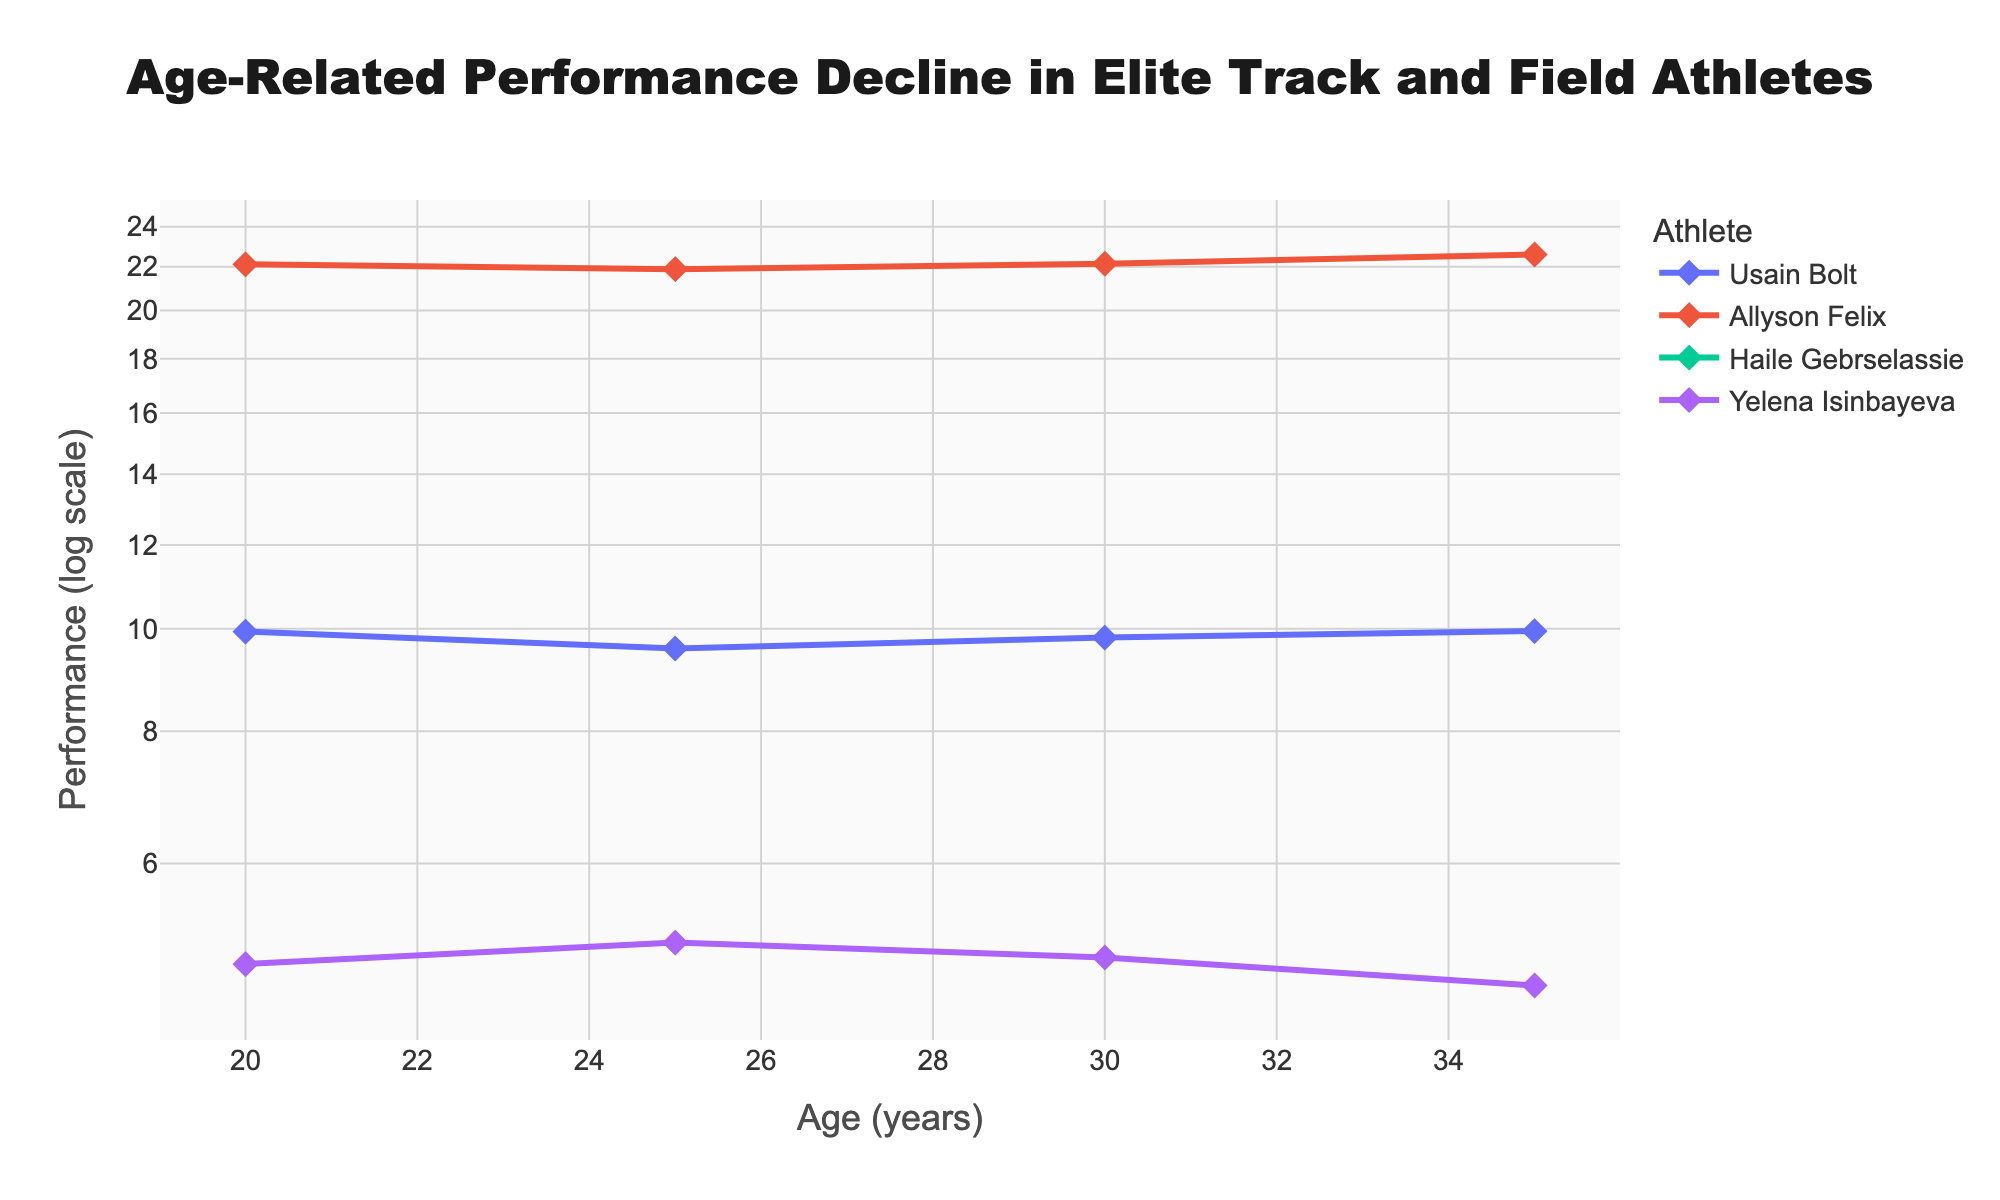What is the title of the figure? The title is typically found at the top of the figure. This one says, "Age-Related Performance Decline in Elite Track and Field Athletes" which clearly indicates the focus of the analysis.
Answer: Age-Related Performance Decline in Elite Track and Field Athletes What is the x-axis labeled with? The x-axis label usually indicates the metric measured along this axis. In this figure, it is labeled with "Age (years)" which shows the age of the athletes.
Answer: Age (years) What is the y-axis labeled with, and what scale is it using? The y-axis label provides information about the metric and scaling used. In this figure, it is labeled "Performance (log scale)," indicating that performance is measured on a logarithmic scale.
Answer: Performance (log scale) How many data points are plotted for Usain Bolt? Each marker on the line represents a data point for the athlete. Usain Bolt's line has markers at ages 20, 25, 30, and 35, which totals to 4 data points.
Answer: 4 At what age did Yelena Isinbayeva achieve her highest performance? By examining the heights of the markers along Yelena Isinbayeva's line, her highest point is at age 25.
Answer: 25 Which athlete shows the smallest performance decline from age 20 to age 25? To determine this, compare the vertical gaps between the performances at ages 20 and 25 across all athletes. Allyson Felix has the smallest decline as her performance slightly improves.
Answer: Allyson Felix How does Allyson Felix's performance at age 35 compare to her performance at age 20? Looking at both markers, Allyson Felix's performance at age 35 is slower compared to age 20. Specifically, it went from 22.11 seconds to 22.59 seconds.
Answer: It's slower at age 35 Who had the fastest performance ever recorded in the dataset and at what age? The smallest numerical value on the performance axis indicates the fastest time. Usain Bolt's performance of 9.58 seconds at age 25 is the fastest.
Answer: Usain Bolt at age 25 By what factor did Haile Gebrselassie's performance change from age 20 to age 30? This requires calculating the ratio between the performances at ages 30 and 20. Converting the times: (12:39.36) = 759.36 seconds and (12:58.56) = 778.56 seconds. The ratio is 778.56 / 759.36 ≈ 1.025.
Answer: Approximately 1.025 Which athlete shows both improvement and decline in performance over the tracked period? By examining each line, Usain Bolt and Haile Gebrselassie show both improvement and subsequent decline. Usain Bolt improves to age 25 then declines, and Haile Gebrselassie has similar trends.
Answer: Usain Bolt and Haile Gebrselassie 